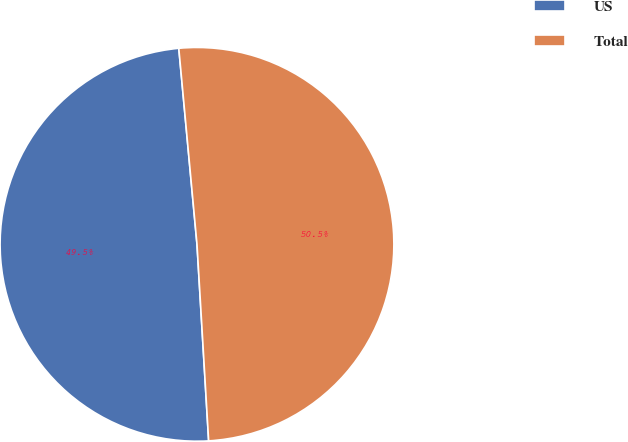Convert chart. <chart><loc_0><loc_0><loc_500><loc_500><pie_chart><fcel>US<fcel>Total<nl><fcel>49.47%<fcel>50.53%<nl></chart> 